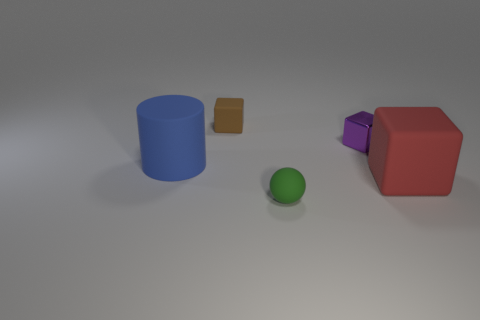Subtract all blue blocks. Subtract all gray balls. How many blocks are left? 3 Add 2 big blue matte cylinders. How many objects exist? 7 Subtract all cylinders. How many objects are left? 4 Subtract all tiny gray rubber balls. Subtract all large blue things. How many objects are left? 4 Add 1 small metal things. How many small metal things are left? 2 Add 1 tiny green metallic spheres. How many tiny green metallic spheres exist? 1 Subtract 0 purple balls. How many objects are left? 5 